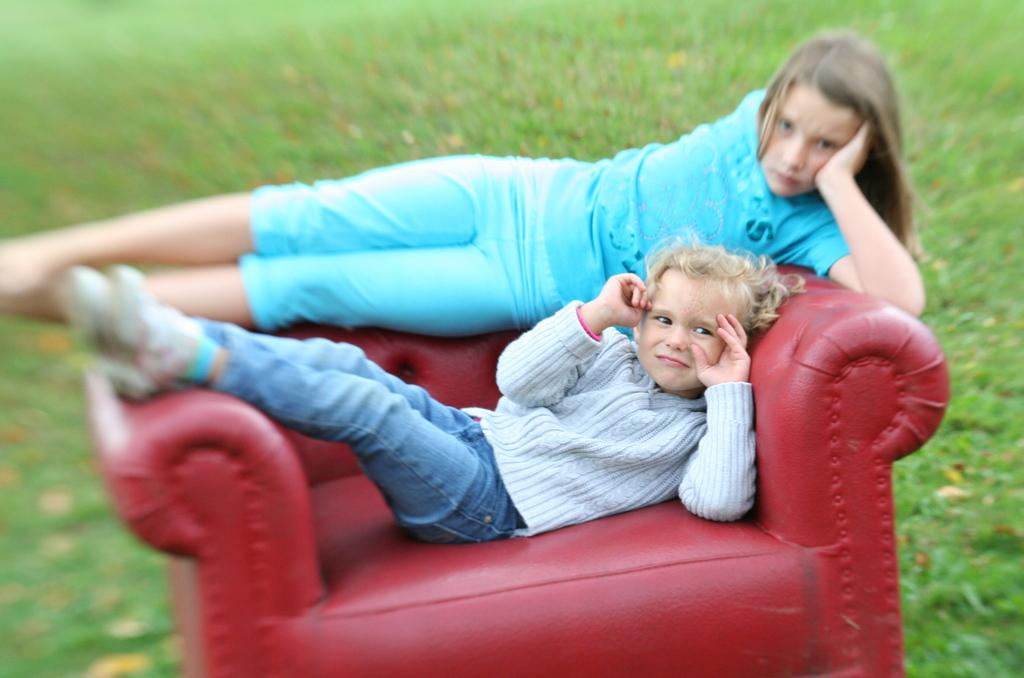Who is present in the image? There are kids in the image. What are the kids doing in the image? The kids are on a couch. Can you describe the background of the image? The background of the image is blurred. What type of net can be seen in the image? There is no net present in the image. How many passengers are visible in the image? There are no passengers present in the image; it features kids on a couch. 